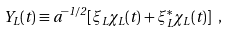Convert formula to latex. <formula><loc_0><loc_0><loc_500><loc_500>Y _ { L } ( t ) \equiv a ^ { - 1 / 2 } [ \xi _ { L } \chi _ { L } ( t ) + \xi _ { L } ^ { * } \chi _ { L } ( t ) ] \ ,</formula> 